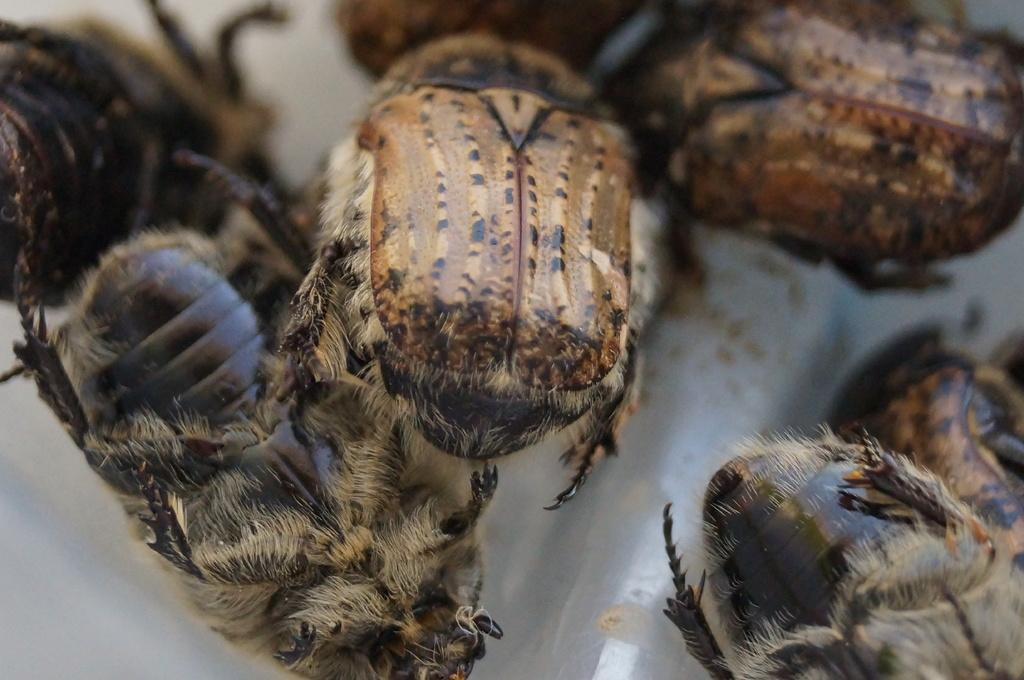What type of creatures can be seen on the surface in the image? There are insects on the surface in the image. What type of sail can be seen on the bear in the image? There is no bear or sail present in the image; it features insects on a surface. 